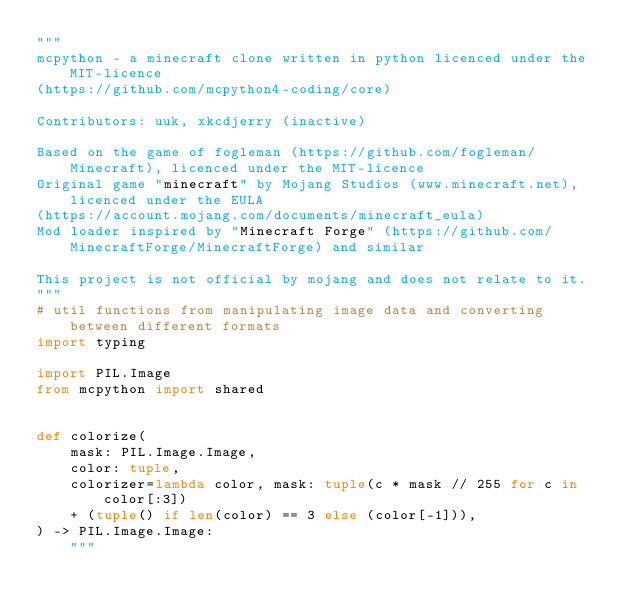<code> <loc_0><loc_0><loc_500><loc_500><_Python_>"""
mcpython - a minecraft clone written in python licenced under the MIT-licence 
(https://github.com/mcpython4-coding/core)

Contributors: uuk, xkcdjerry (inactive)

Based on the game of fogleman (https://github.com/fogleman/Minecraft), licenced under the MIT-licence
Original game "minecraft" by Mojang Studios (www.minecraft.net), licenced under the EULA
(https://account.mojang.com/documents/minecraft_eula)
Mod loader inspired by "Minecraft Forge" (https://github.com/MinecraftForge/MinecraftForge) and similar

This project is not official by mojang and does not relate to it.
"""
# util functions from manipulating image data and converting between different formats
import typing

import PIL.Image
from mcpython import shared


def colorize(
    mask: PIL.Image.Image,
    color: tuple,
    colorizer=lambda color, mask: tuple(c * mask // 255 for c in color[:3])
    + (tuple() if len(color) == 3 else (color[-1])),
) -> PIL.Image.Image:
    """</code> 